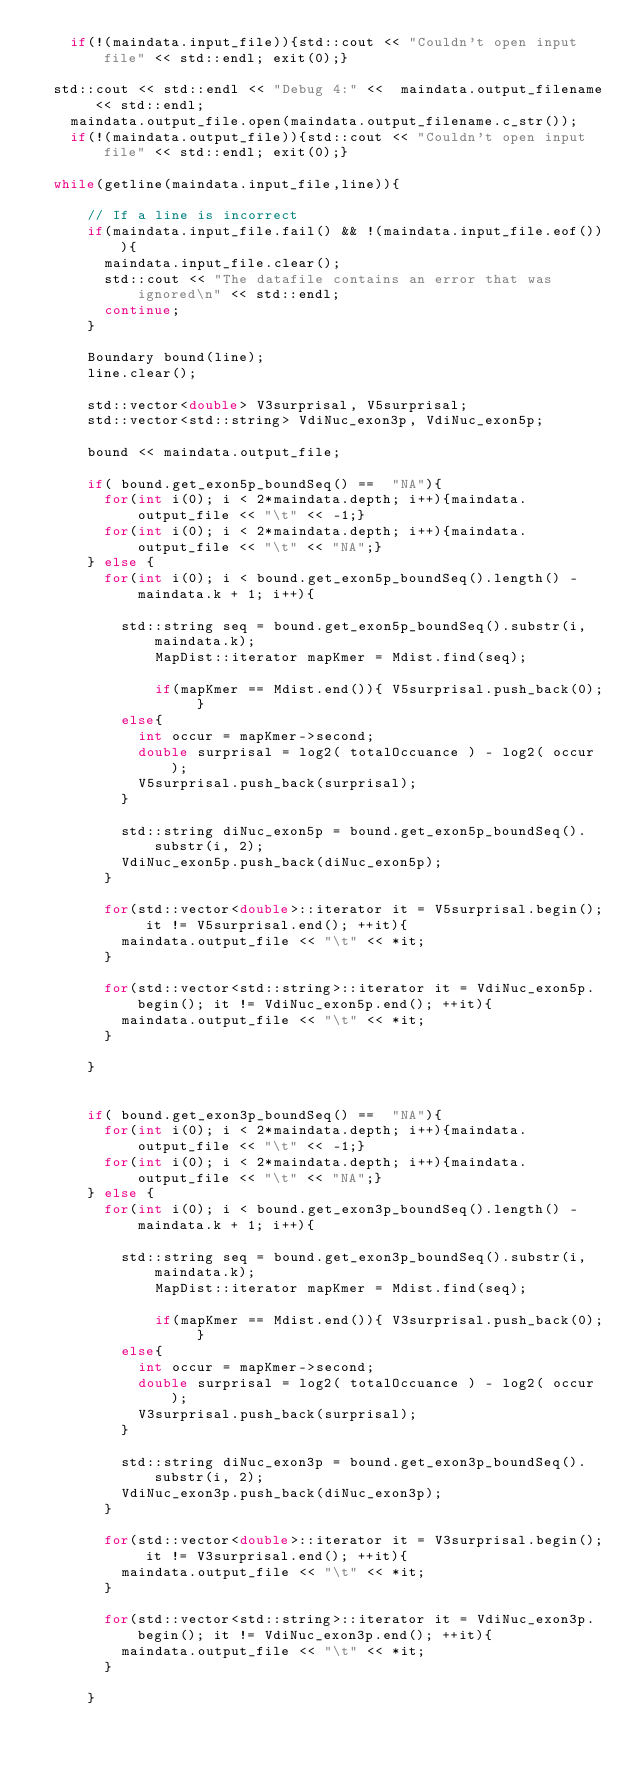<code> <loc_0><loc_0><loc_500><loc_500><_C++_>    if(!(maindata.input_file)){std::cout << "Couldn't open input file" << std::endl; exit(0);}

	std::cout << std::endl << "Debug 4:" <<  maindata.output_filename << std::endl;
    maindata.output_file.open(maindata.output_filename.c_str());
    if(!(maindata.output_file)){std::cout << "Couldn't open input file" << std::endl; exit(0);}

	while(getline(maindata.input_file,line)){

			// If a line is incorrect
			if(maindata.input_file.fail() && !(maindata.input_file.eof())){
				maindata.input_file.clear();
				std::cout << "The datafile contains an error that was ignored\n" << std::endl;
				continue;
			}

			Boundary bound(line);
			line.clear();

			std::vector<double> V3surprisal, V5surprisal;
			std::vector<std::string> VdiNuc_exon3p, VdiNuc_exon5p;

			bound << maindata.output_file;

			if( bound.get_exon5p_boundSeq() ==  "NA"){
				for(int i(0); i < 2*maindata.depth; i++){maindata.output_file << "\t" << -1;}
				for(int i(0); i < 2*maindata.depth; i++){maindata.output_file << "\t" << "NA";}
			} else {
				for(int i(0); i < bound.get_exon5p_boundSeq().length() - maindata.k + 1; i++){

					std::string seq = bound.get_exon5p_boundSeq().substr(i, maindata.k);
			        MapDist::iterator mapKmer = Mdist.find(seq);

			        if(mapKmer == Mdist.end()){ V5surprisal.push_back(0); }
					else{ 
						int occur = mapKmer->second; 
						double surprisal = log2( totalOccuance ) - log2( occur );
						V5surprisal.push_back(surprisal);
					}

					std::string diNuc_exon5p = bound.get_exon5p_boundSeq().substr(i, 2);
					VdiNuc_exon5p.push_back(diNuc_exon5p);
				}
	
				for(std::vector<double>::iterator it = V5surprisal.begin(); it != V5surprisal.end(); ++it){
					maindata.output_file << "\t" << *it;
				}
				
				for(std::vector<std::string>::iterator it = VdiNuc_exon5p.begin(); it != VdiNuc_exon5p.end(); ++it){
					maindata.output_file << "\t" << *it;
				}
				
			} 


			if( bound.get_exon3p_boundSeq() ==  "NA"){
				for(int i(0); i < 2*maindata.depth; i++){maindata.output_file << "\t" << -1;}
				for(int i(0); i < 2*maindata.depth; i++){maindata.output_file << "\t" << "NA";}
			} else {
				for(int i(0); i < bound.get_exon3p_boundSeq().length() - maindata.k + 1; i++){

					std::string seq = bound.get_exon3p_boundSeq().substr(i, maindata.k);
			        MapDist::iterator mapKmer = Mdist.find(seq);

			        if(mapKmer == Mdist.end()){ V3surprisal.push_back(0); }
					else{ 
						int occur = mapKmer->second; 
						double surprisal = log2( totalOccuance ) - log2( occur );
						V3surprisal.push_back(surprisal);
					}

					std::string diNuc_exon3p = bound.get_exon3p_boundSeq().substr(i, 2);
					VdiNuc_exon3p.push_back(diNuc_exon3p);
				}
	
				for(std::vector<double>::iterator it = V3surprisal.begin(); it != V3surprisal.end(); ++it){
					maindata.output_file << "\t" << *it;
				}
				
				for(std::vector<std::string>::iterator it = VdiNuc_exon3p.begin(); it != VdiNuc_exon3p.end(); ++it){
					maindata.output_file << "\t" << *it;
				}
				
			} 
</code> 